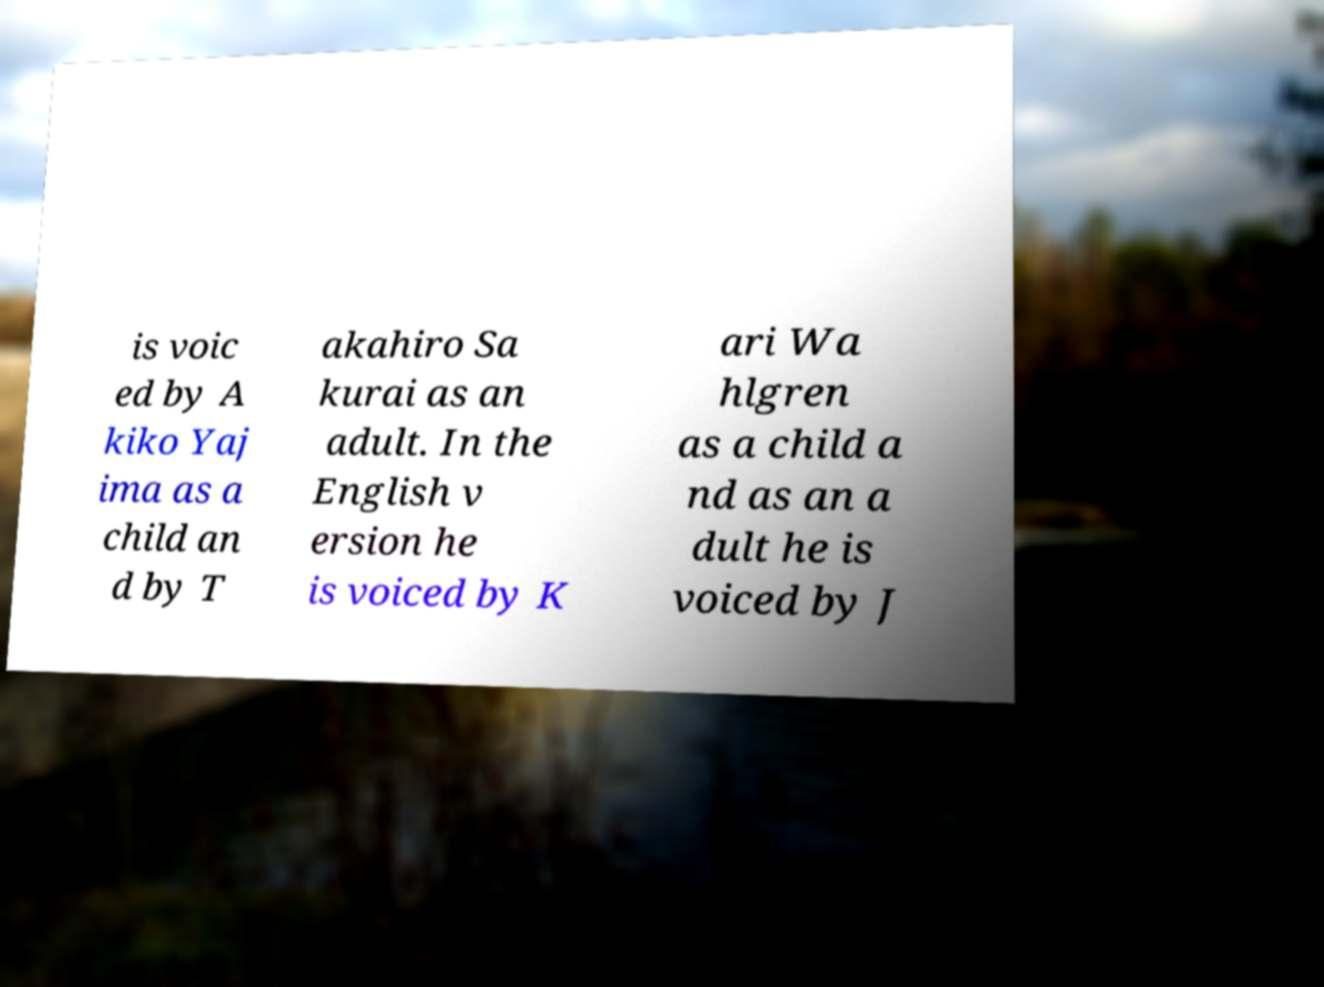Can you accurately transcribe the text from the provided image for me? is voic ed by A kiko Yaj ima as a child an d by T akahiro Sa kurai as an adult. In the English v ersion he is voiced by K ari Wa hlgren as a child a nd as an a dult he is voiced by J 